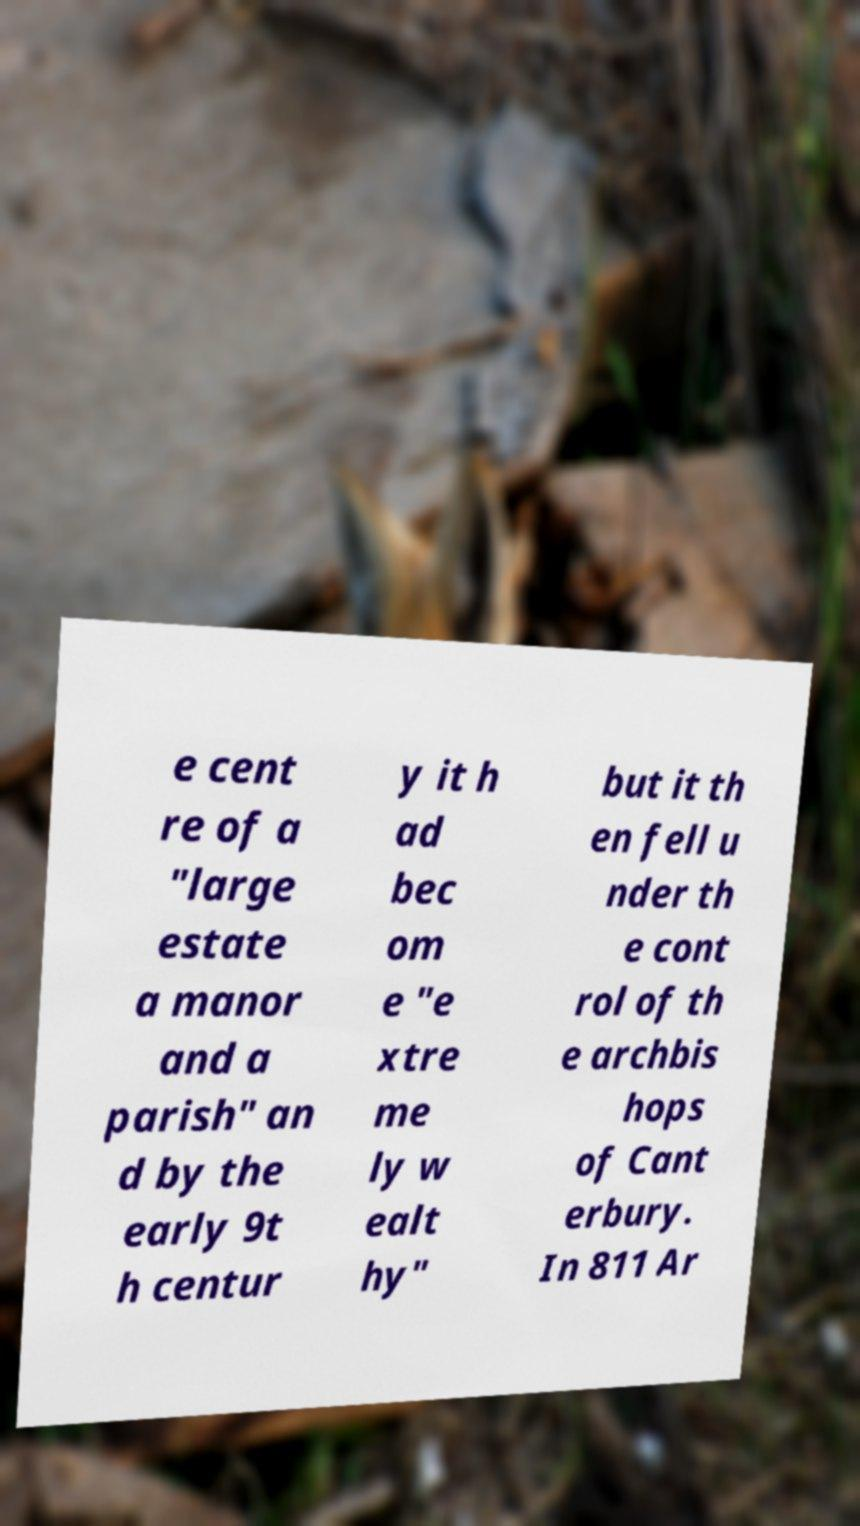Please identify and transcribe the text found in this image. e cent re of a "large estate a manor and a parish" an d by the early 9t h centur y it h ad bec om e "e xtre me ly w ealt hy" but it th en fell u nder th e cont rol of th e archbis hops of Cant erbury. In 811 Ar 